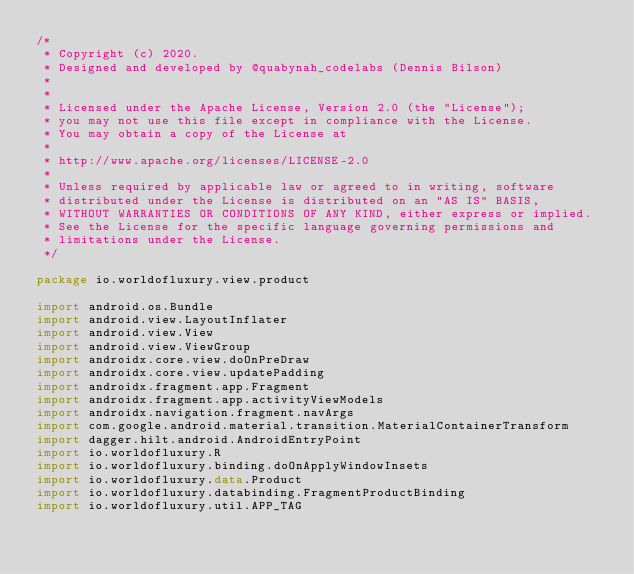Convert code to text. <code><loc_0><loc_0><loc_500><loc_500><_Kotlin_>/*
 * Copyright (c) 2020.
 * Designed and developed by @quabynah_codelabs (Dennis Bilson)
 *
 *
 * Licensed under the Apache License, Version 2.0 (the "License");
 * you may not use this file except in compliance with the License.
 * You may obtain a copy of the License at
 *
 * http://www.apache.org/licenses/LICENSE-2.0
 *
 * Unless required by applicable law or agreed to in writing, software
 * distributed under the License is distributed on an "AS IS" BASIS,
 * WITHOUT WARRANTIES OR CONDITIONS OF ANY KIND, either express or implied.
 * See the License for the specific language governing permissions and
 * limitations under the License.
 */

package io.worldofluxury.view.product

import android.os.Bundle
import android.view.LayoutInflater
import android.view.View
import android.view.ViewGroup
import androidx.core.view.doOnPreDraw
import androidx.core.view.updatePadding
import androidx.fragment.app.Fragment
import androidx.fragment.app.activityViewModels
import androidx.navigation.fragment.navArgs
import com.google.android.material.transition.MaterialContainerTransform
import dagger.hilt.android.AndroidEntryPoint
import io.worldofluxury.R
import io.worldofluxury.binding.doOnApplyWindowInsets
import io.worldofluxury.data.Product
import io.worldofluxury.databinding.FragmentProductBinding
import io.worldofluxury.util.APP_TAG</code> 